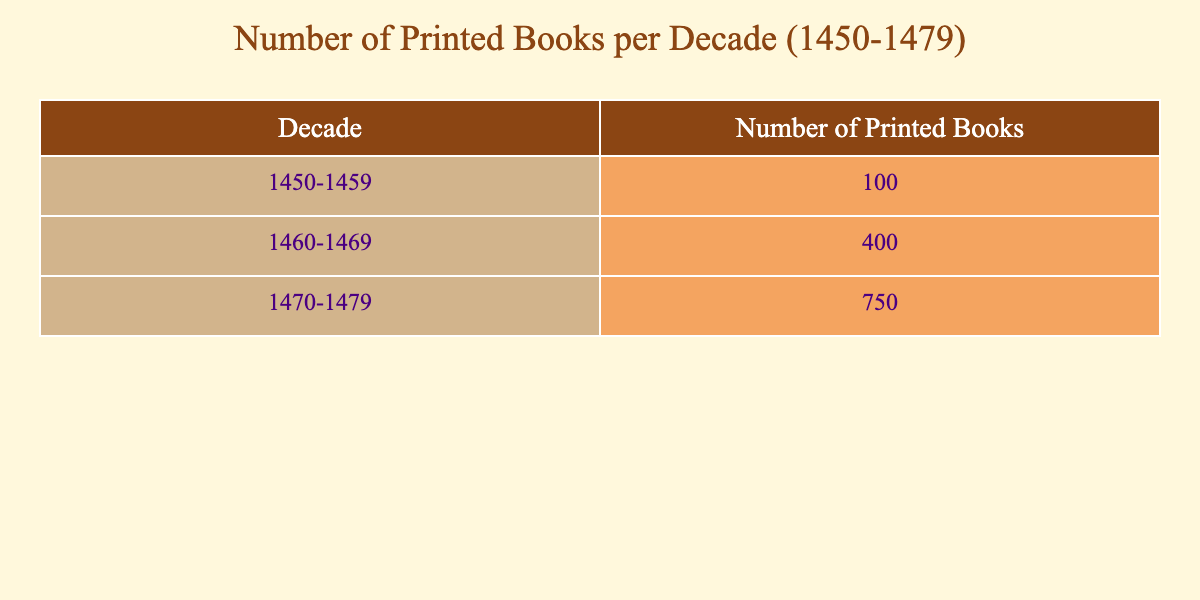What was the total number of printed books published in the decade of 1460-1469? To find the total for the decade 1460-1469, I can refer directly to the table and locate the number listed for that decade, which is 400.
Answer: 400 How many more printed books were published in the decade of 1470-1479 compared to 1450-1459? I will subtract the number of printed books in 1450-1459 (100) from the number in 1470-1479 (750). The calculation is 750 - 100 = 650.
Answer: 650 Is the number of printed books published in 1460-1469 greater than that in 1450-1459? I can compare the figures from the two decades; 400 (1460-1469) is indeed greater than 100 (1450-1459), confirming that the statement is true.
Answer: Yes What is the total number of printed books published from 1450 to 1479? To find the total, I will sum the numbers from each decade: 100 (1450-1459) + 400 (1460-1469) + 750 (1470-1479) = 1250.
Answer: 1250 Was the number of printed books published in the decade of 1470-1479 the highest among the three decades listed? The numbers from the decades are: 100, 400, and 750. Since 750 is greater than both 100 and 400, the answer confirms that 1470-1479 had the highest publication.
Answer: Yes What is the average number of printed books published per decade from 1450-1479? To find the average, I will add the total number of printed books (1250) and divide by the number of decades (3). The calculation is 1250 / 3, which yields approximately 416.67.
Answer: 416.67 How many decades had more than 300 printed books published? By examining the table, I see that the decades of 1460-1469 and 1470-1479 both have numbers greater than 300, while 1450-1459 does not. Therefore, there are 2 decades.
Answer: 2 What is the difference in the number of printed books between the decades of 1460-1469 and 1470-1479? I subtract the number for 1460-1469 (400) from that for 1470-1479 (750): 750 - 400 = 350, which represents the difference in their publication numbers.
Answer: 350 